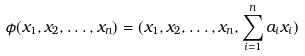<formula> <loc_0><loc_0><loc_500><loc_500>\phi ( x _ { 1 } , x _ { 2 } , \dots , x _ { n } ) = ( x _ { 1 } , x _ { 2 } , \dots , x _ { n } , \sum _ { i = 1 } ^ { n } a _ { i } x _ { i } )</formula> 